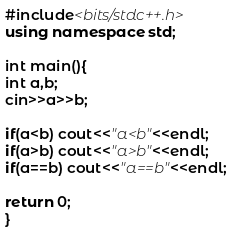Convert code to text. <code><loc_0><loc_0><loc_500><loc_500><_C++_>#include<bits/stdc++.h>
using namespace std;

int main(){
int a,b;
cin>>a>>b;

if(a<b) cout<<"a<b"<<endl;
if(a>b) cout<<"a>b"<<endl;
if(a==b) cout<<"a==b"<<endl;

return 0;
}
</code> 